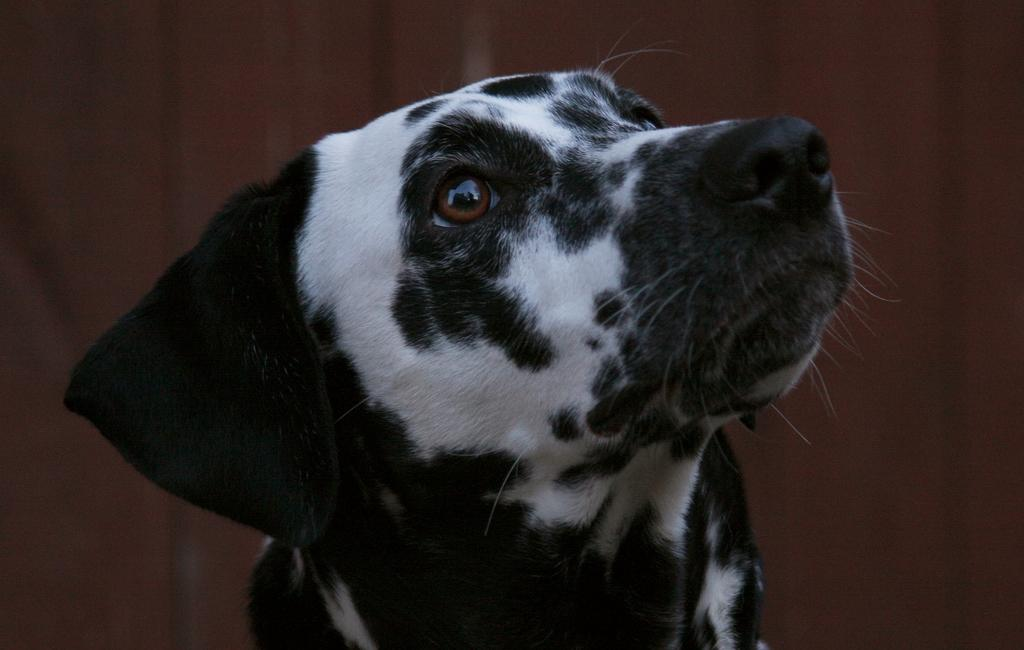What type of animal is in the image? There is a dog in the image. What can be observed about the background of the image? The background of the image is dark. Who is the expert in the image? There is no expert present in the image; it features a dog and a dark background. What part of the dog is visible in the image? The provided facts do not specify which part of the dog is visible, so it cannot be determined from the information given. 